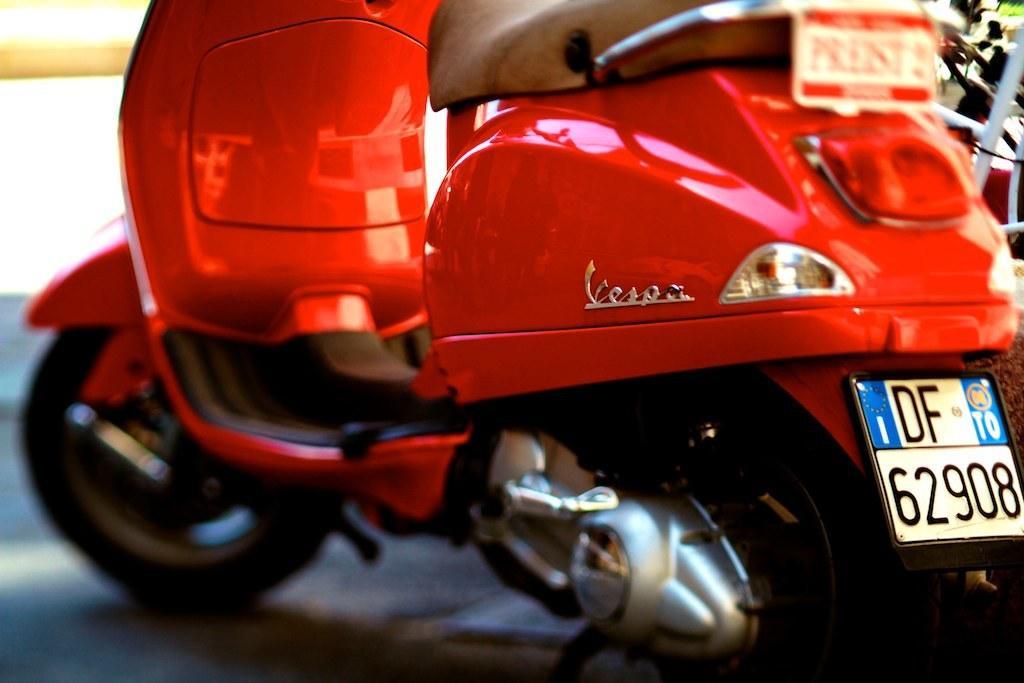Can you describe this image briefly? In this image I can see a motorbike which is red and black in color on the ground. In the background I can see few other vehicles. 